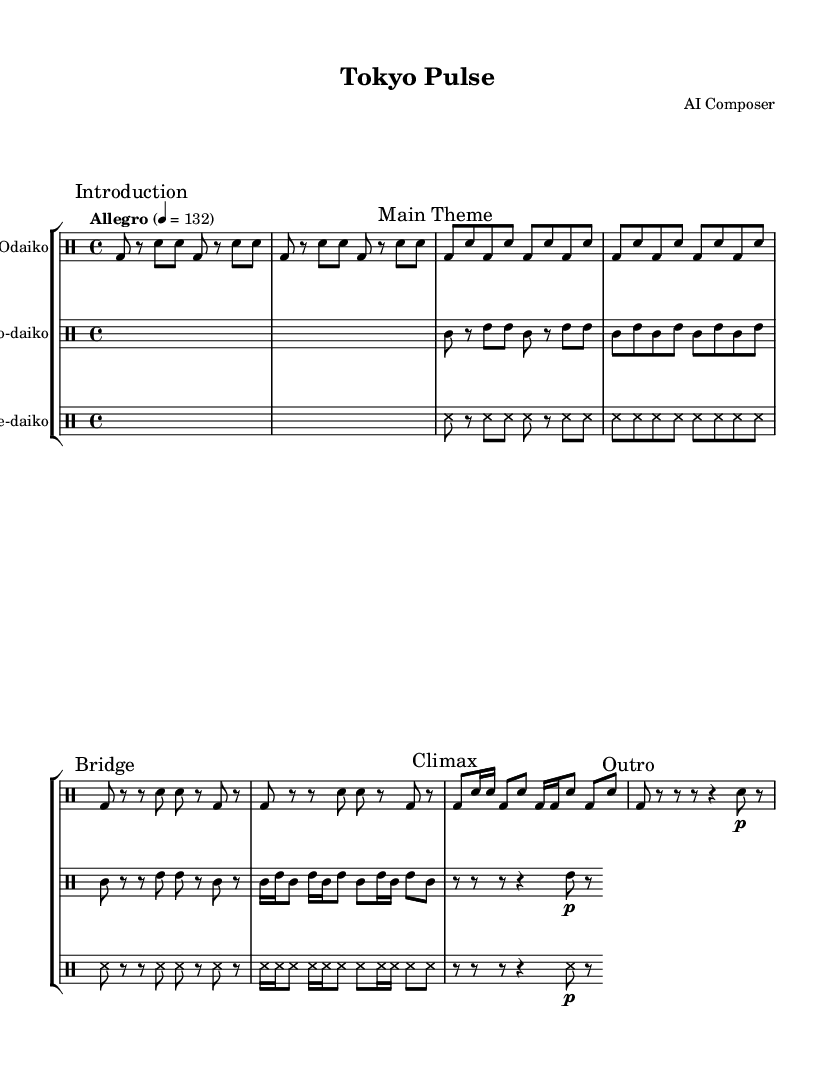What is the time signature of this music? The time signature is specified in the music sheet with "4/4," indicating four beats per measure.
Answer: 4/4 What is the tempo marking provided in the score? The tempo marking in the score is denoted as "Allegro" with a metronome indication of 132 beats per minute, suggesting a brisk pace.
Answer: Allegro 4 = 132 How many distinct sections are indicated in the odaiko part? The odaiko drumming part includes marked sections labeled "Introduction," "Main Theme," "Bridge," "Climax," and "Outro," that's a total of five distinct sections.
Answer: 5 What type of rhythmic figure is predominantly used in the "skyscraperBuild" section? The "skyscraperBuild" section features alternating bass and snare drum patterns, predominantly using eighth notes (bd8 and sn8), which creates a driving rhythm akin to a metropolitan skyline construction.
Answer: Eighth notes What distinguishes the shime-daiko pattern from the nagado-daiko pattern in terms of rhythmic density? The shime-daiko pattern features more extensive use of shorter note values (e.g., sixteenth notes), ensuring a denser and faster rhythmic output compared to the wider spacing of nagado-daiko rhythms characterized by longer note values.
Answer: Shorter note values Which instrument is marked as the main theme's featured performer? The odaiko is specified to perform the main theme with its powerful sound and large, resonant body, making it the featured performer in this section.
Answer: Odaiko 